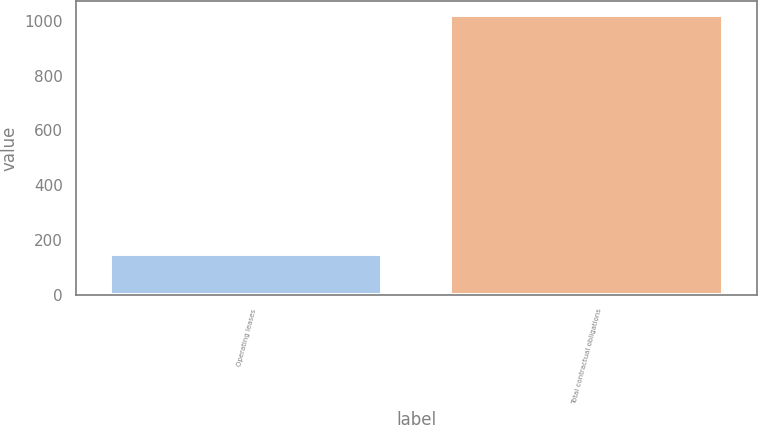<chart> <loc_0><loc_0><loc_500><loc_500><bar_chart><fcel>Operating leases<fcel>Total contractual obligations<nl><fcel>149.3<fcel>1020.1<nl></chart> 